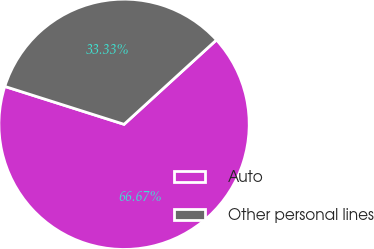Convert chart to OTSL. <chart><loc_0><loc_0><loc_500><loc_500><pie_chart><fcel>Auto<fcel>Other personal lines<nl><fcel>66.67%<fcel>33.33%<nl></chart> 